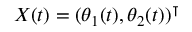Convert formula to latex. <formula><loc_0><loc_0><loc_500><loc_500>X ( t ) = ( \theta _ { 1 } ( t ) , \theta _ { 2 } ( t ) ) ^ { \intercal }</formula> 